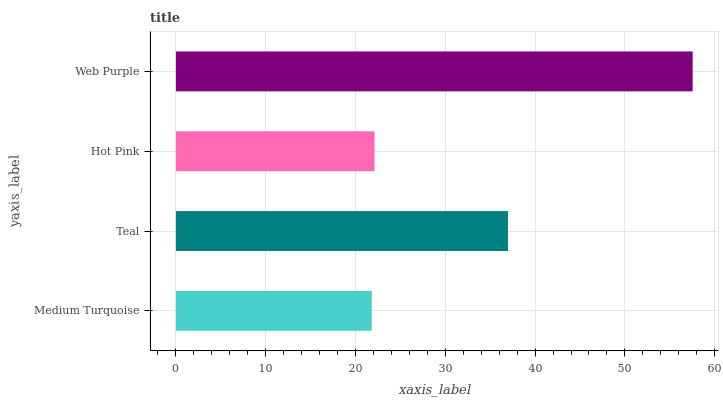Is Medium Turquoise the minimum?
Answer yes or no. Yes. Is Web Purple the maximum?
Answer yes or no. Yes. Is Teal the minimum?
Answer yes or no. No. Is Teal the maximum?
Answer yes or no. No. Is Teal greater than Medium Turquoise?
Answer yes or no. Yes. Is Medium Turquoise less than Teal?
Answer yes or no. Yes. Is Medium Turquoise greater than Teal?
Answer yes or no. No. Is Teal less than Medium Turquoise?
Answer yes or no. No. Is Teal the high median?
Answer yes or no. Yes. Is Hot Pink the low median?
Answer yes or no. Yes. Is Hot Pink the high median?
Answer yes or no. No. Is Medium Turquoise the low median?
Answer yes or no. No. 